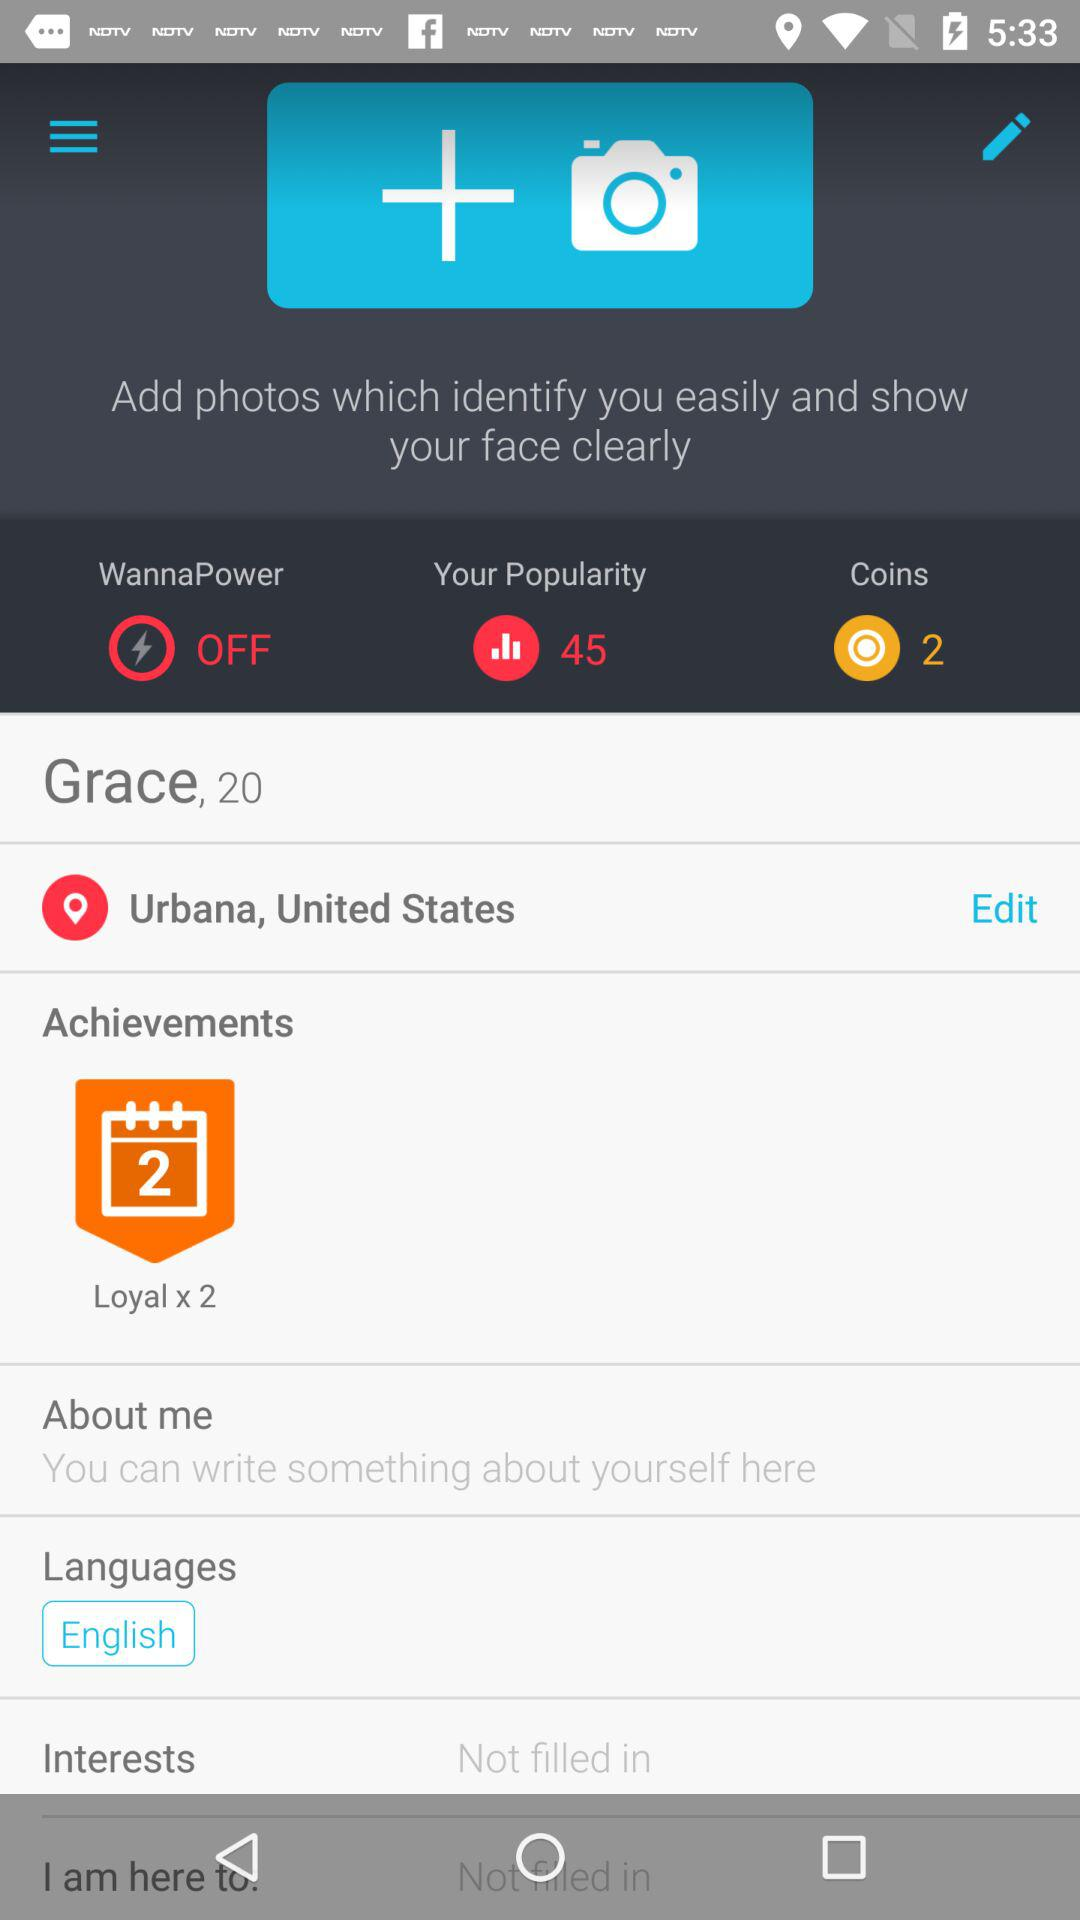What language is selected? The selected language is English. 